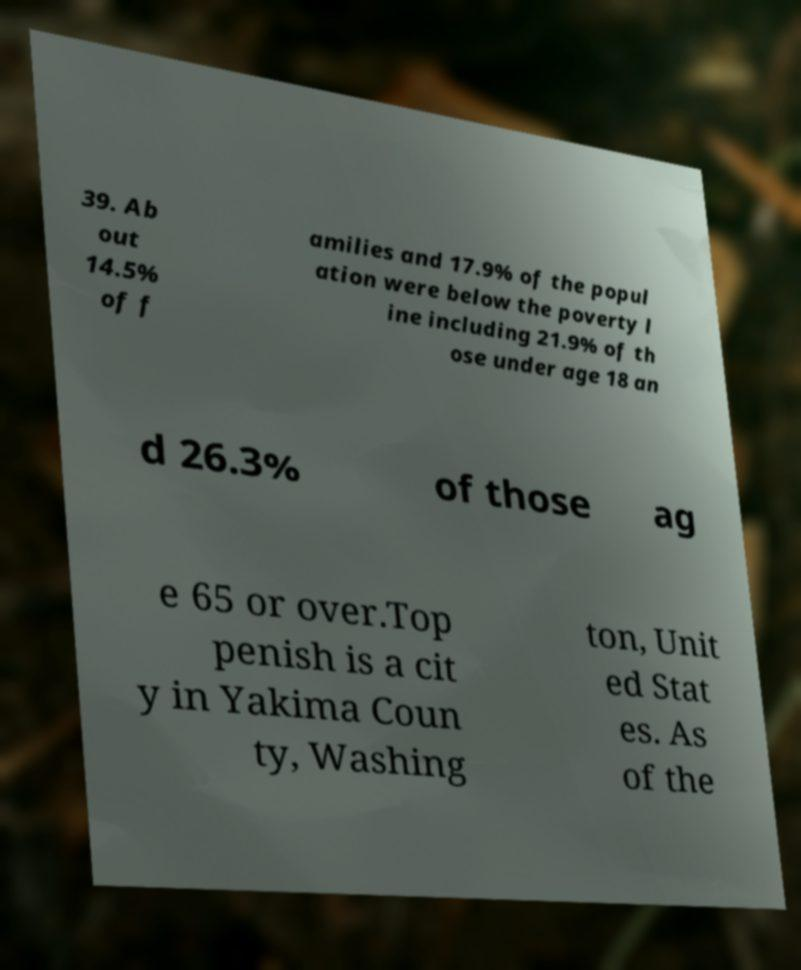There's text embedded in this image that I need extracted. Can you transcribe it verbatim? 39. Ab out 14.5% of f amilies and 17.9% of the popul ation were below the poverty l ine including 21.9% of th ose under age 18 an d 26.3% of those ag e 65 or over.Top penish is a cit y in Yakima Coun ty, Washing ton, Unit ed Stat es. As of the 